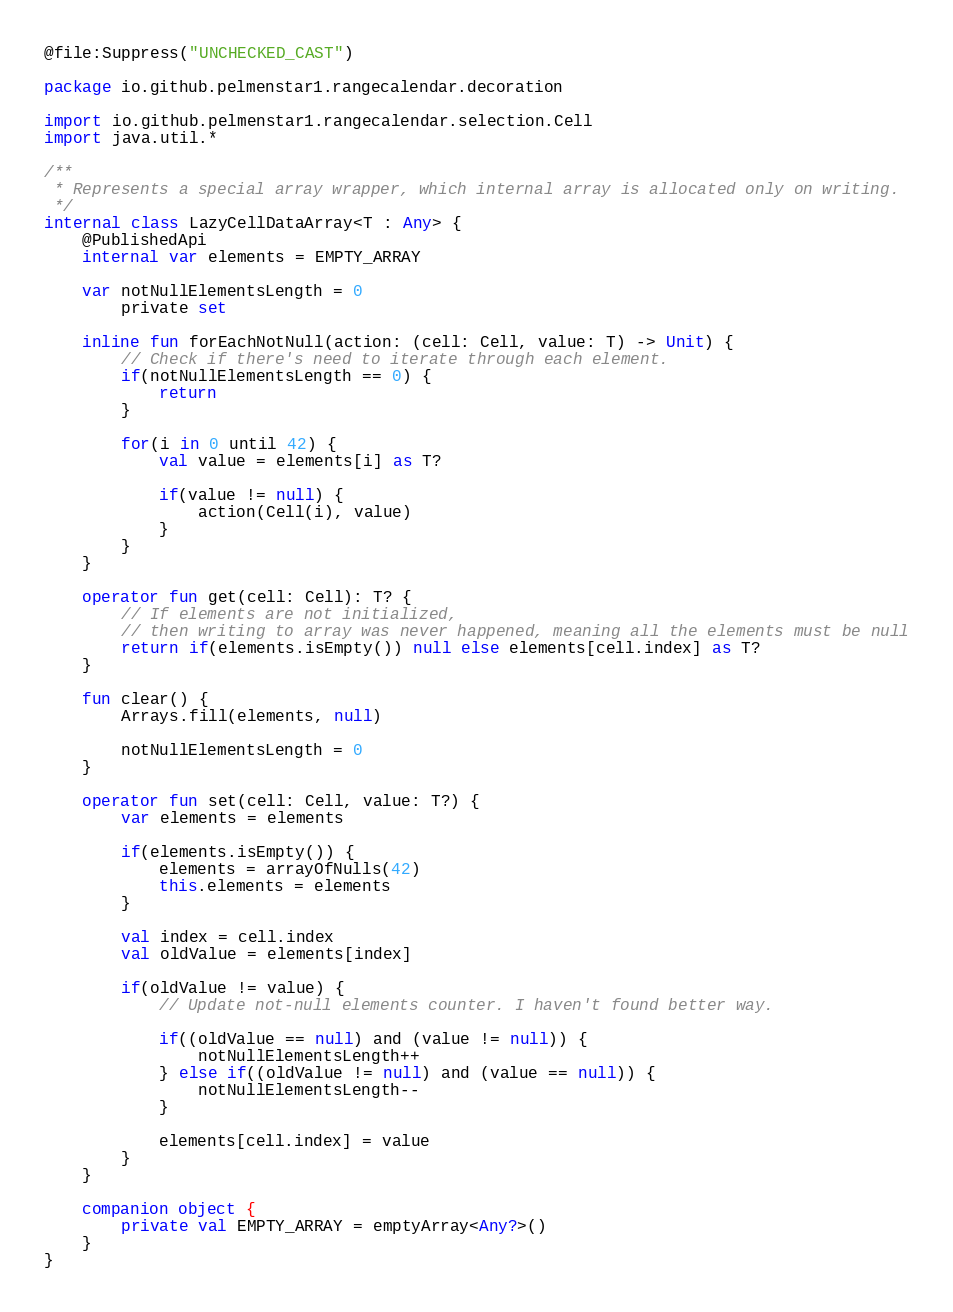Convert code to text. <code><loc_0><loc_0><loc_500><loc_500><_Kotlin_>@file:Suppress("UNCHECKED_CAST")

package io.github.pelmenstar1.rangecalendar.decoration

import io.github.pelmenstar1.rangecalendar.selection.Cell
import java.util.*

/**
 * Represents a special array wrapper, which internal array is allocated only on writing.
 */
internal class LazyCellDataArray<T : Any> {
    @PublishedApi
    internal var elements = EMPTY_ARRAY

    var notNullElementsLength = 0
        private set

    inline fun forEachNotNull(action: (cell: Cell, value: T) -> Unit) {
        // Check if there's need to iterate through each element.
        if(notNullElementsLength == 0) {
            return
        }

        for(i in 0 until 42) {
            val value = elements[i] as T?

            if(value != null) {
                action(Cell(i), value)
            }
        }
    }

    operator fun get(cell: Cell): T? {
        // If elements are not initialized,
        // then writing to array was never happened, meaning all the elements must be null
        return if(elements.isEmpty()) null else elements[cell.index] as T?
    }

    fun clear() {
        Arrays.fill(elements, null)

        notNullElementsLength = 0
    }

    operator fun set(cell: Cell, value: T?) {
        var elements = elements

        if(elements.isEmpty()) {
            elements = arrayOfNulls(42)
            this.elements = elements
        }

        val index = cell.index
        val oldValue = elements[index]

        if(oldValue != value) {
            // Update not-null elements counter. I haven't found better way.

            if((oldValue == null) and (value != null)) {
                notNullElementsLength++
            } else if((oldValue != null) and (value == null)) {
                notNullElementsLength--
            }

            elements[cell.index] = value
        }
    }

    companion object {
        private val EMPTY_ARRAY = emptyArray<Any?>()
    }
}</code> 